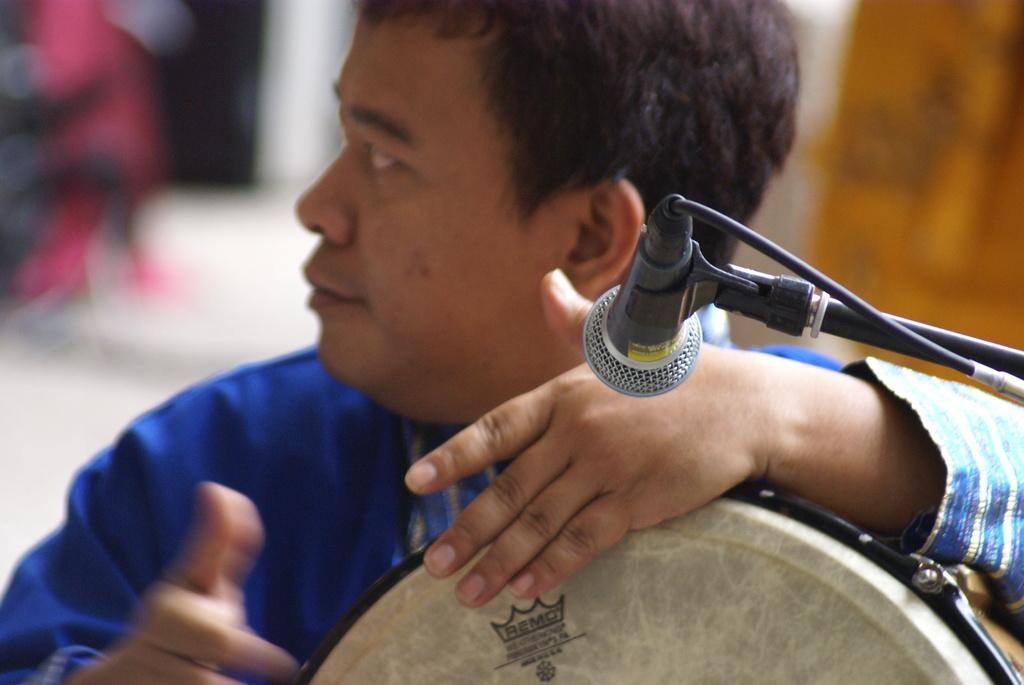What is the main subject of the image? There is a person in the image. What is the person doing in the image? The person is beating drums. What object is present in the image that might be used for amplifying sound? There is a microphone in the image. How many kittens can be seen playing with the pan in the image? There are no kittens or pans present in the image. 